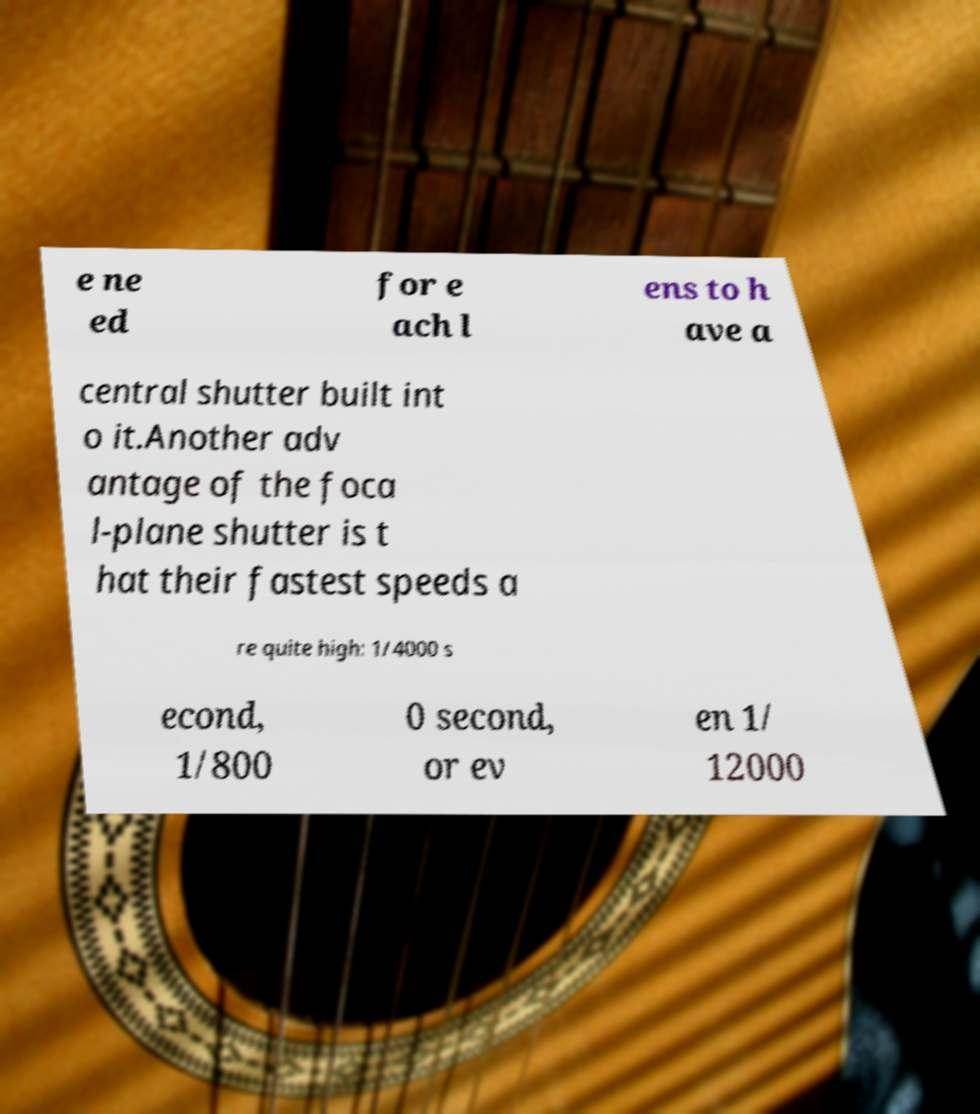What messages or text are displayed in this image? I need them in a readable, typed format. e ne ed for e ach l ens to h ave a central shutter built int o it.Another adv antage of the foca l-plane shutter is t hat their fastest speeds a re quite high: 1/4000 s econd, 1/800 0 second, or ev en 1/ 12000 